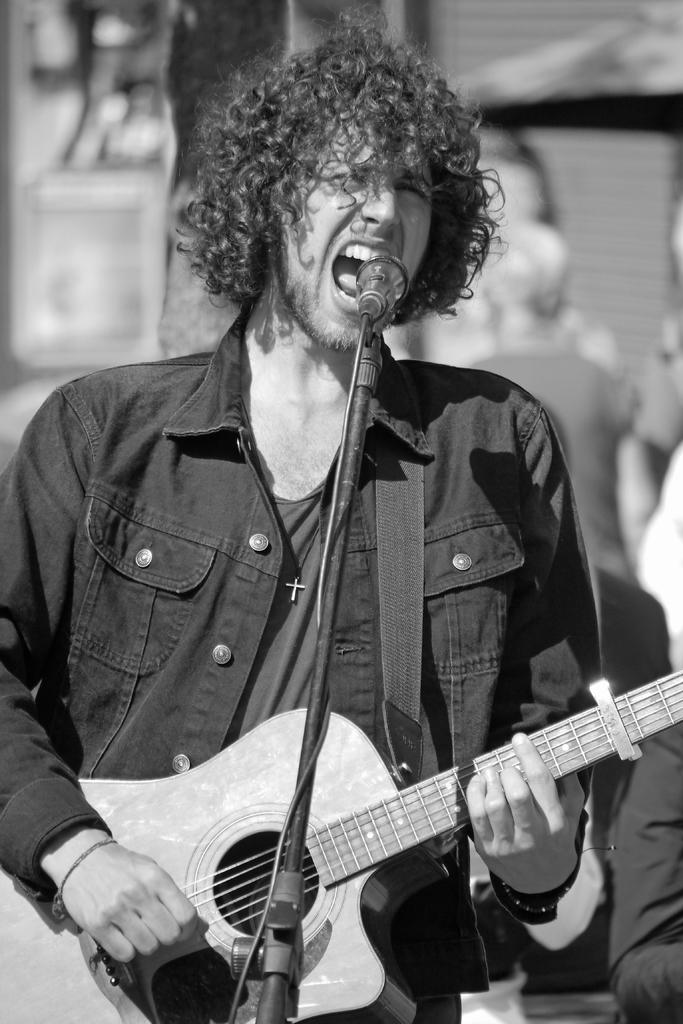What is the man in the image doing? The man is playing a guitar. How is the man positioned in the image? The man is standing. What object is in front of the man? There is a microphone in front of the man. Can you describe the background of the image? There are people in the background of the image. How does the man sort the faucet in the image? There is no faucet present in the image, so the man cannot sort it. 